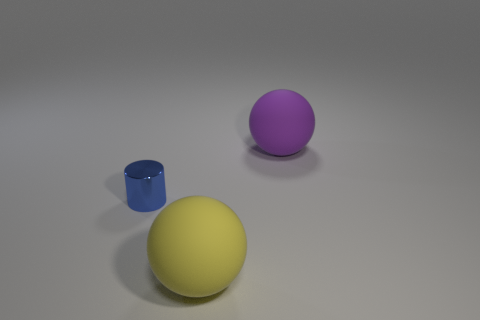Add 1 blue metal cylinders. How many objects exist? 4 Subtract all yellow spheres. How many spheres are left? 1 Subtract 0 blue spheres. How many objects are left? 3 Subtract all cylinders. How many objects are left? 2 Subtract all yellow spheres. Subtract all yellow cubes. How many spheres are left? 1 Subtract all yellow cubes. How many purple balls are left? 1 Subtract all yellow things. Subtract all big blue cylinders. How many objects are left? 2 Add 1 small blue metallic cylinders. How many small blue metallic cylinders are left? 2 Add 3 tiny blue objects. How many tiny blue objects exist? 4 